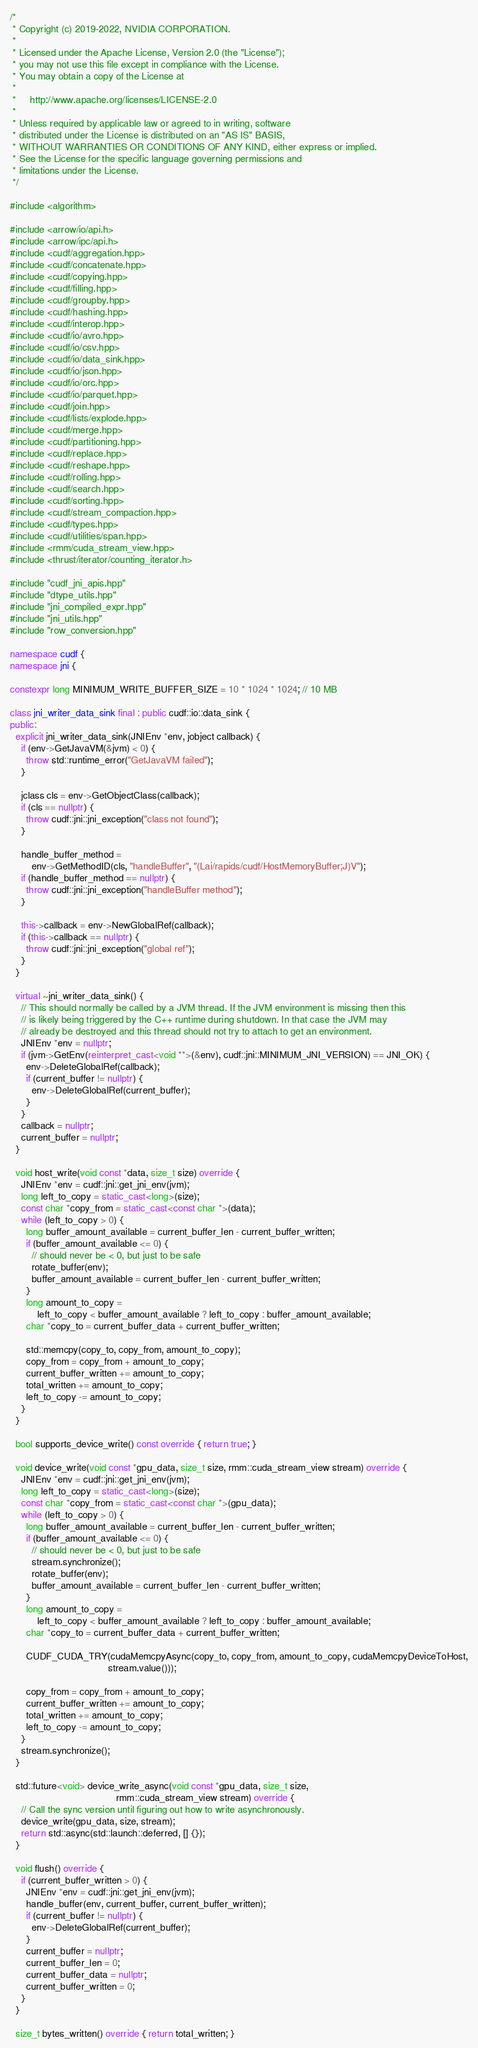Convert code to text. <code><loc_0><loc_0><loc_500><loc_500><_C++_>/*
 * Copyright (c) 2019-2022, NVIDIA CORPORATION.
 *
 * Licensed under the Apache License, Version 2.0 (the "License");
 * you may not use this file except in compliance with the License.
 * You may obtain a copy of the License at
 *
 *     http://www.apache.org/licenses/LICENSE-2.0
 *
 * Unless required by applicable law or agreed to in writing, software
 * distributed under the License is distributed on an "AS IS" BASIS,
 * WITHOUT WARRANTIES OR CONDITIONS OF ANY KIND, either express or implied.
 * See the License for the specific language governing permissions and
 * limitations under the License.
 */

#include <algorithm>

#include <arrow/io/api.h>
#include <arrow/ipc/api.h>
#include <cudf/aggregation.hpp>
#include <cudf/concatenate.hpp>
#include <cudf/copying.hpp>
#include <cudf/filling.hpp>
#include <cudf/groupby.hpp>
#include <cudf/hashing.hpp>
#include <cudf/interop.hpp>
#include <cudf/io/avro.hpp>
#include <cudf/io/csv.hpp>
#include <cudf/io/data_sink.hpp>
#include <cudf/io/json.hpp>
#include <cudf/io/orc.hpp>
#include <cudf/io/parquet.hpp>
#include <cudf/join.hpp>
#include <cudf/lists/explode.hpp>
#include <cudf/merge.hpp>
#include <cudf/partitioning.hpp>
#include <cudf/replace.hpp>
#include <cudf/reshape.hpp>
#include <cudf/rolling.hpp>
#include <cudf/search.hpp>
#include <cudf/sorting.hpp>
#include <cudf/stream_compaction.hpp>
#include <cudf/types.hpp>
#include <cudf/utilities/span.hpp>
#include <rmm/cuda_stream_view.hpp>
#include <thrust/iterator/counting_iterator.h>

#include "cudf_jni_apis.hpp"
#include "dtype_utils.hpp"
#include "jni_compiled_expr.hpp"
#include "jni_utils.hpp"
#include "row_conversion.hpp"

namespace cudf {
namespace jni {

constexpr long MINIMUM_WRITE_BUFFER_SIZE = 10 * 1024 * 1024; // 10 MB

class jni_writer_data_sink final : public cudf::io::data_sink {
public:
  explicit jni_writer_data_sink(JNIEnv *env, jobject callback) {
    if (env->GetJavaVM(&jvm) < 0) {
      throw std::runtime_error("GetJavaVM failed");
    }

    jclass cls = env->GetObjectClass(callback);
    if (cls == nullptr) {
      throw cudf::jni::jni_exception("class not found");
    }

    handle_buffer_method =
        env->GetMethodID(cls, "handleBuffer", "(Lai/rapids/cudf/HostMemoryBuffer;J)V");
    if (handle_buffer_method == nullptr) {
      throw cudf::jni::jni_exception("handleBuffer method");
    }

    this->callback = env->NewGlobalRef(callback);
    if (this->callback == nullptr) {
      throw cudf::jni::jni_exception("global ref");
    }
  }

  virtual ~jni_writer_data_sink() {
    // This should normally be called by a JVM thread. If the JVM environment is missing then this
    // is likely being triggered by the C++ runtime during shutdown. In that case the JVM may
    // already be destroyed and this thread should not try to attach to get an environment.
    JNIEnv *env = nullptr;
    if (jvm->GetEnv(reinterpret_cast<void **>(&env), cudf::jni::MINIMUM_JNI_VERSION) == JNI_OK) {
      env->DeleteGlobalRef(callback);
      if (current_buffer != nullptr) {
        env->DeleteGlobalRef(current_buffer);
      }
    }
    callback = nullptr;
    current_buffer = nullptr;
  }

  void host_write(void const *data, size_t size) override {
    JNIEnv *env = cudf::jni::get_jni_env(jvm);
    long left_to_copy = static_cast<long>(size);
    const char *copy_from = static_cast<const char *>(data);
    while (left_to_copy > 0) {
      long buffer_amount_available = current_buffer_len - current_buffer_written;
      if (buffer_amount_available <= 0) {
        // should never be < 0, but just to be safe
        rotate_buffer(env);
        buffer_amount_available = current_buffer_len - current_buffer_written;
      }
      long amount_to_copy =
          left_to_copy < buffer_amount_available ? left_to_copy : buffer_amount_available;
      char *copy_to = current_buffer_data + current_buffer_written;

      std::memcpy(copy_to, copy_from, amount_to_copy);
      copy_from = copy_from + amount_to_copy;
      current_buffer_written += amount_to_copy;
      total_written += amount_to_copy;
      left_to_copy -= amount_to_copy;
    }
  }

  bool supports_device_write() const override { return true; }

  void device_write(void const *gpu_data, size_t size, rmm::cuda_stream_view stream) override {
    JNIEnv *env = cudf::jni::get_jni_env(jvm);
    long left_to_copy = static_cast<long>(size);
    const char *copy_from = static_cast<const char *>(gpu_data);
    while (left_to_copy > 0) {
      long buffer_amount_available = current_buffer_len - current_buffer_written;
      if (buffer_amount_available <= 0) {
        // should never be < 0, but just to be safe
        stream.synchronize();
        rotate_buffer(env);
        buffer_amount_available = current_buffer_len - current_buffer_written;
      }
      long amount_to_copy =
          left_to_copy < buffer_amount_available ? left_to_copy : buffer_amount_available;
      char *copy_to = current_buffer_data + current_buffer_written;

      CUDF_CUDA_TRY(cudaMemcpyAsync(copy_to, copy_from, amount_to_copy, cudaMemcpyDeviceToHost,
                                    stream.value()));

      copy_from = copy_from + amount_to_copy;
      current_buffer_written += amount_to_copy;
      total_written += amount_to_copy;
      left_to_copy -= amount_to_copy;
    }
    stream.synchronize();
  }

  std::future<void> device_write_async(void const *gpu_data, size_t size,
                                       rmm::cuda_stream_view stream) override {
    // Call the sync version until figuring out how to write asynchronously.
    device_write(gpu_data, size, stream);
    return std::async(std::launch::deferred, [] {});
  }

  void flush() override {
    if (current_buffer_written > 0) {
      JNIEnv *env = cudf::jni::get_jni_env(jvm);
      handle_buffer(env, current_buffer, current_buffer_written);
      if (current_buffer != nullptr) {
        env->DeleteGlobalRef(current_buffer);
      }
      current_buffer = nullptr;
      current_buffer_len = 0;
      current_buffer_data = nullptr;
      current_buffer_written = 0;
    }
  }

  size_t bytes_written() override { return total_written; }
</code> 